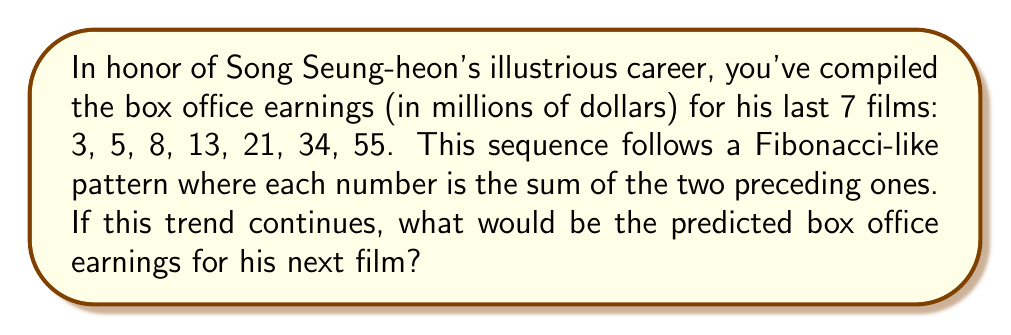What is the answer to this math problem? Let's analyze this Fibonacci-like sequence step-by-step:

1) First, we confirm that each number is indeed the sum of the two preceding ones:
   $3 + 5 = 8$
   $5 + 8 = 13$
   $8 + 13 = 21$
   $13 + 21 = 34$
   $21 + 34 = 55$

2) The general formula for this type of sequence is:

   $F_n = F_{n-1} + F_{n-2}$

   Where $F_n$ is the nth term in the sequence.

3) To find the next number in the sequence, we need to add the last two numbers:

   $F_8 = F_7 + F_6$

4) We know that $F_7 = 55$ and $F_6 = 34$, so:

   $F_8 = 55 + 34 = 89$

Therefore, if the trend continues, the predicted box office earnings for Song Seung-heon's next film would be $89 million.
Answer: $89 million 